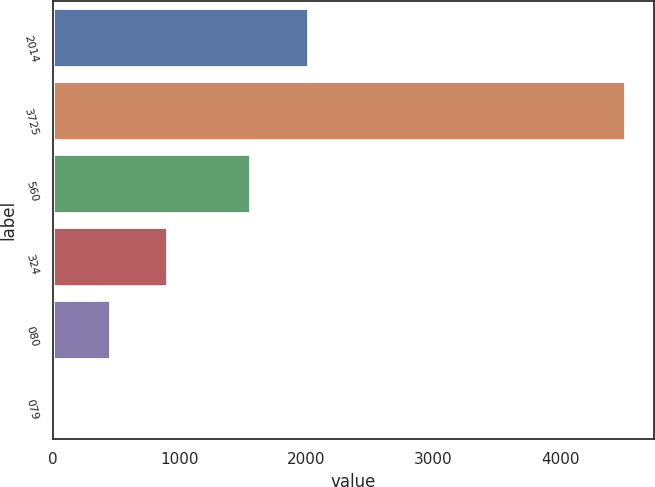<chart> <loc_0><loc_0><loc_500><loc_500><bar_chart><fcel>2014<fcel>3725<fcel>560<fcel>324<fcel>080<fcel>079<nl><fcel>2014<fcel>4510<fcel>1554<fcel>903.32<fcel>452.48<fcel>1.64<nl></chart> 